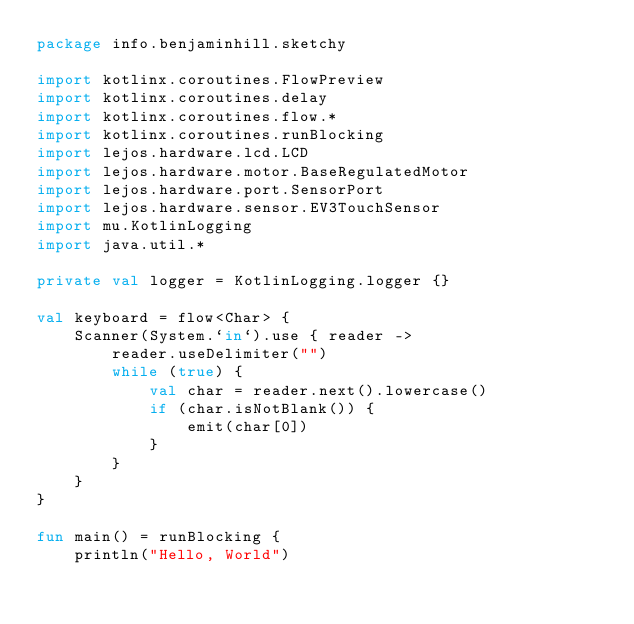<code> <loc_0><loc_0><loc_500><loc_500><_Kotlin_>package info.benjaminhill.sketchy

import kotlinx.coroutines.FlowPreview
import kotlinx.coroutines.delay
import kotlinx.coroutines.flow.*
import kotlinx.coroutines.runBlocking
import lejos.hardware.lcd.LCD
import lejos.hardware.motor.BaseRegulatedMotor
import lejos.hardware.port.SensorPort
import lejos.hardware.sensor.EV3TouchSensor
import mu.KotlinLogging
import java.util.*

private val logger = KotlinLogging.logger {}

val keyboard = flow<Char> {
    Scanner(System.`in`).use { reader ->
        reader.useDelimiter("")
        while (true) {
            val char = reader.next().lowercase()
            if (char.isNotBlank()) {
                emit(char[0])
            }
        }
    }
}

fun main() = runBlocking {
    println("Hello, World")</code> 